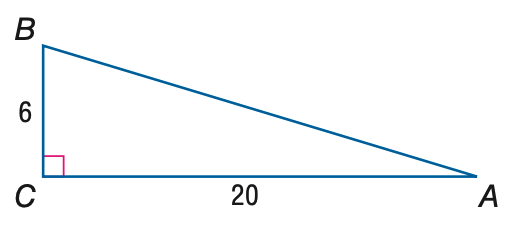Answer the mathemtical geometry problem and directly provide the correct option letter.
Question: Find the measure of \angle A to the nearest tenth.
Choices: A: 16.7 B: 17.5 C: 72.5 D: 73.3 A 